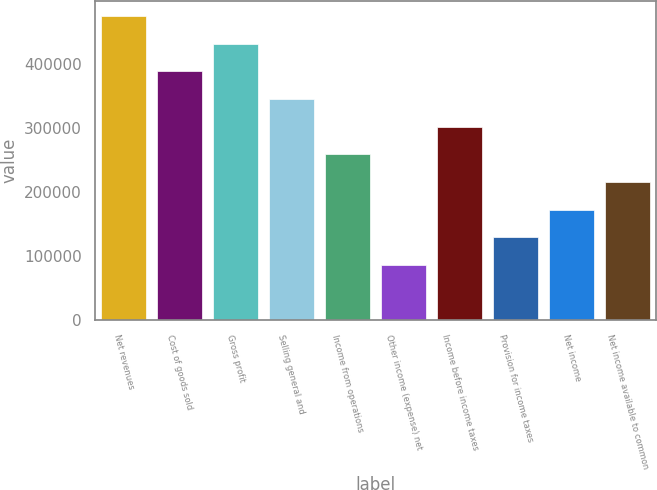Convert chart. <chart><loc_0><loc_0><loc_500><loc_500><bar_chart><fcel>Net revenues<fcel>Cost of goods sold<fcel>Gross profit<fcel>Selling general and<fcel>Income from operations<fcel>Other income (expense) net<fcel>Income before income taxes<fcel>Provision for income taxes<fcel>Net income<fcel>Net income available to common<nl><fcel>473758<fcel>387620<fcel>430689<fcel>344551<fcel>258414<fcel>86138.4<fcel>301483<fcel>129207<fcel>172276<fcel>215345<nl></chart> 